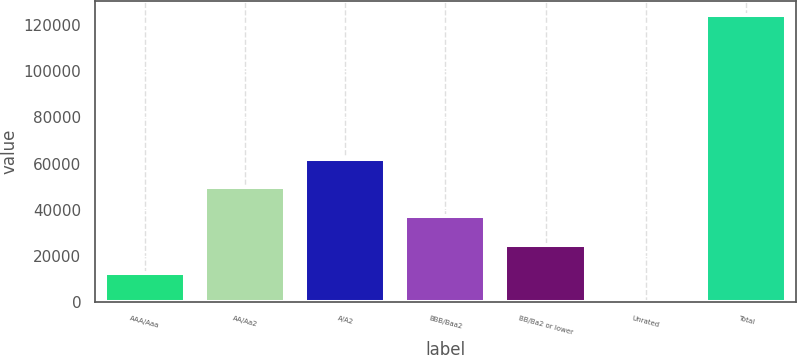<chart> <loc_0><loc_0><loc_500><loc_500><bar_chart><fcel>AAA/Aaa<fcel>AA/Aa2<fcel>A/A2<fcel>BBB/Baa2<fcel>BB/Ba2 or lower<fcel>Unrated<fcel>Total<nl><fcel>12537.6<fcel>49799.4<fcel>62220<fcel>37378.8<fcel>24958.2<fcel>117<fcel>124323<nl></chart> 